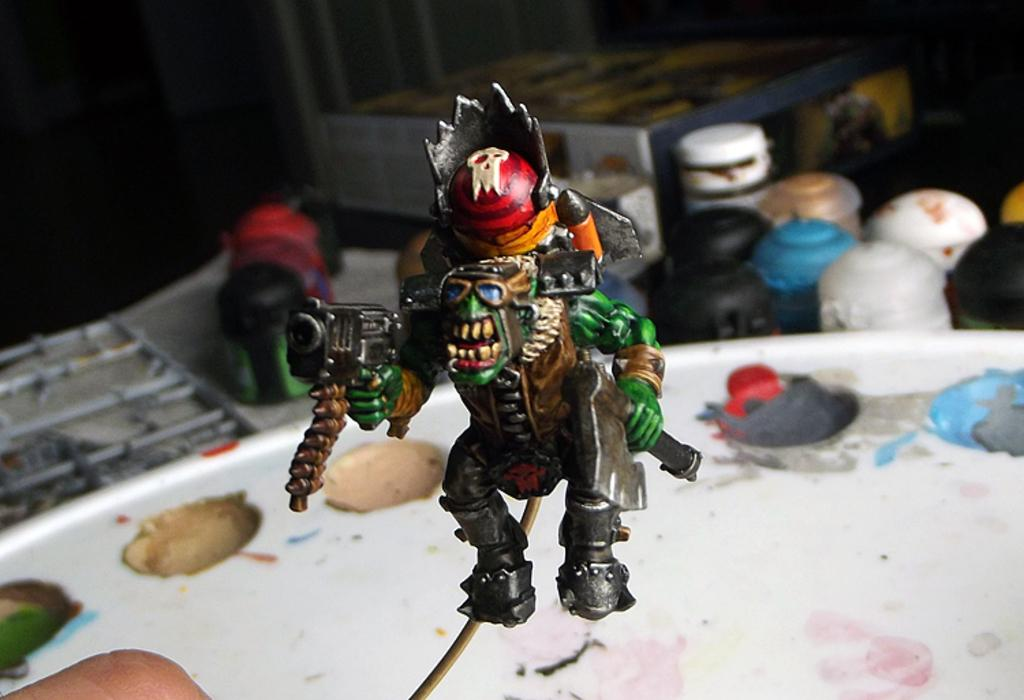What object can be seen in the image that is meant for play or entertainment? There is a toy in the image. What object in the image is used for storage or organization? There is a box in the image. Whose hand is visible in the image? A person's hand is visible in the image. What other objects can be seen in the image, besides the toy and box? There are some unspecified objects in the image. How would you describe the lighting in the image? The background of the image is dark. How does the heart beat in the image? There is no heart present in the image, so it is not possible to determine how it might beat. 